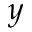Convert formula to latex. <formula><loc_0><loc_0><loc_500><loc_500>y</formula> 